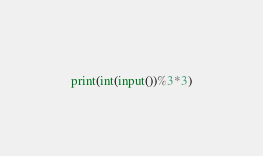<code> <loc_0><loc_0><loc_500><loc_500><_Python_>print(int(input())%3*3)</code> 